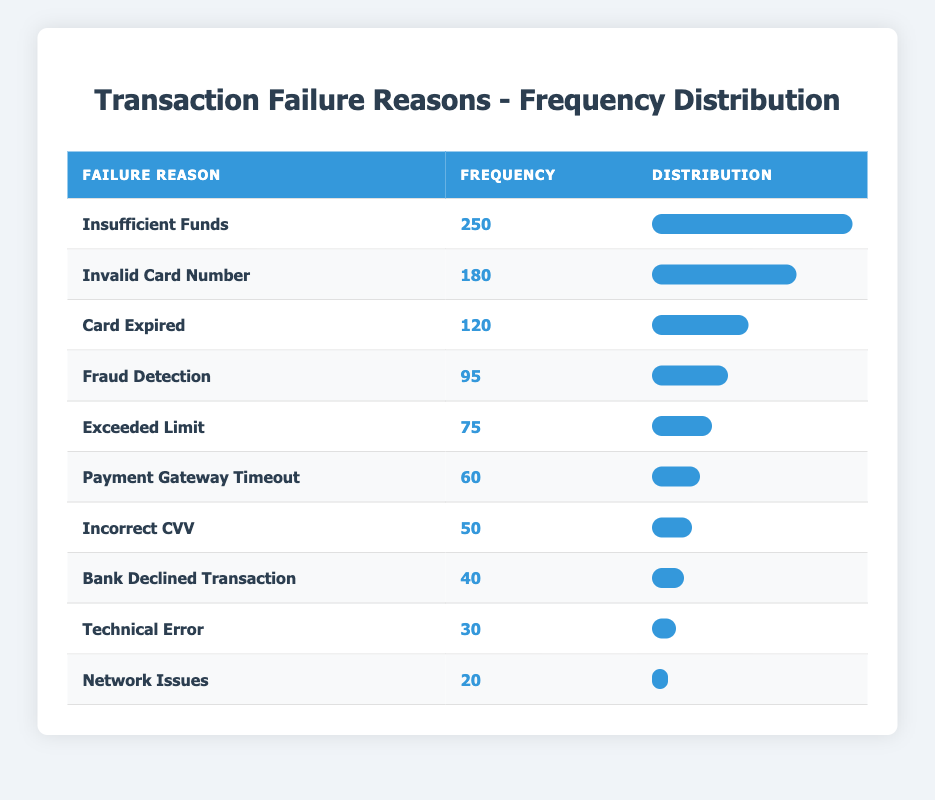What is the most common reason for transaction failures? The table displays the frequency of various transaction failure reasons. By scanning the 'Frequency' column, "Insufficient Funds" is listed first with a frequency of 250, indicating it is the most common reason for failures.
Answer: Insufficient Funds What is the frequency of "Network Issues"? The table shows that "Network Issues" has a frequency of 20, which is directly listed in the 'Frequency' column.
Answer: 20 What is the total frequency of all the transaction failures? To find the total frequency, we add up the frequencies from each row: 250 + 180 + 120 + 95 + 60 + 75 + 30 + 50 + 40 + 20 = 950. Therefore, the total frequency of transaction failures is 950.
Answer: 950 Is "Card Expired" the least common reason for transaction failures? Reviewing the list, "Card Expired" has a frequency of 120. The least common reason is "Network Issues" with a frequency of 20, thus "Card Expired" is not the least common reason.
Answer: No How many reasons have a frequency of 75 or less? By examining the table, the reasons with a frequency of 75 or less are "Payment Gateway Timeout" (60), "Incorrect CVV" (50), "Bank Declined Transaction" (40), "Technical Error" (30), and "Network Issues" (20). That gives us a total of 5 reasons.
Answer: 5 Which reason has a frequency just above 100 and what is that frequency? Looking at the frequencies, "Invalid Card Number" (180) is just above 100. The next option after it is "Card Expired" (120), which fulfills this condition.
Answer: Card Expired: 120 What is the difference in frequency between the most common and the least common reason for transaction failures? Looking at the frequencies, "Insufficient Funds" has the highest at 250, and "Network Issues" has the lowest at 20. The difference is calculated as 250 - 20 = 230.
Answer: 230 How many reasons have a frequency greater than 50? Checking the table, the reasons with a frequency greater than 50 are: "Insufficient Funds" (250), "Invalid Card Number" (180), "Card Expired" (120), "Fraud Detection" (95), "Exceeded Limit" (75), and "Payment Gateway Timeout" (60). That makes a total of 6 reasons.
Answer: 6 